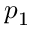Convert formula to latex. <formula><loc_0><loc_0><loc_500><loc_500>p _ { 1 }</formula> 